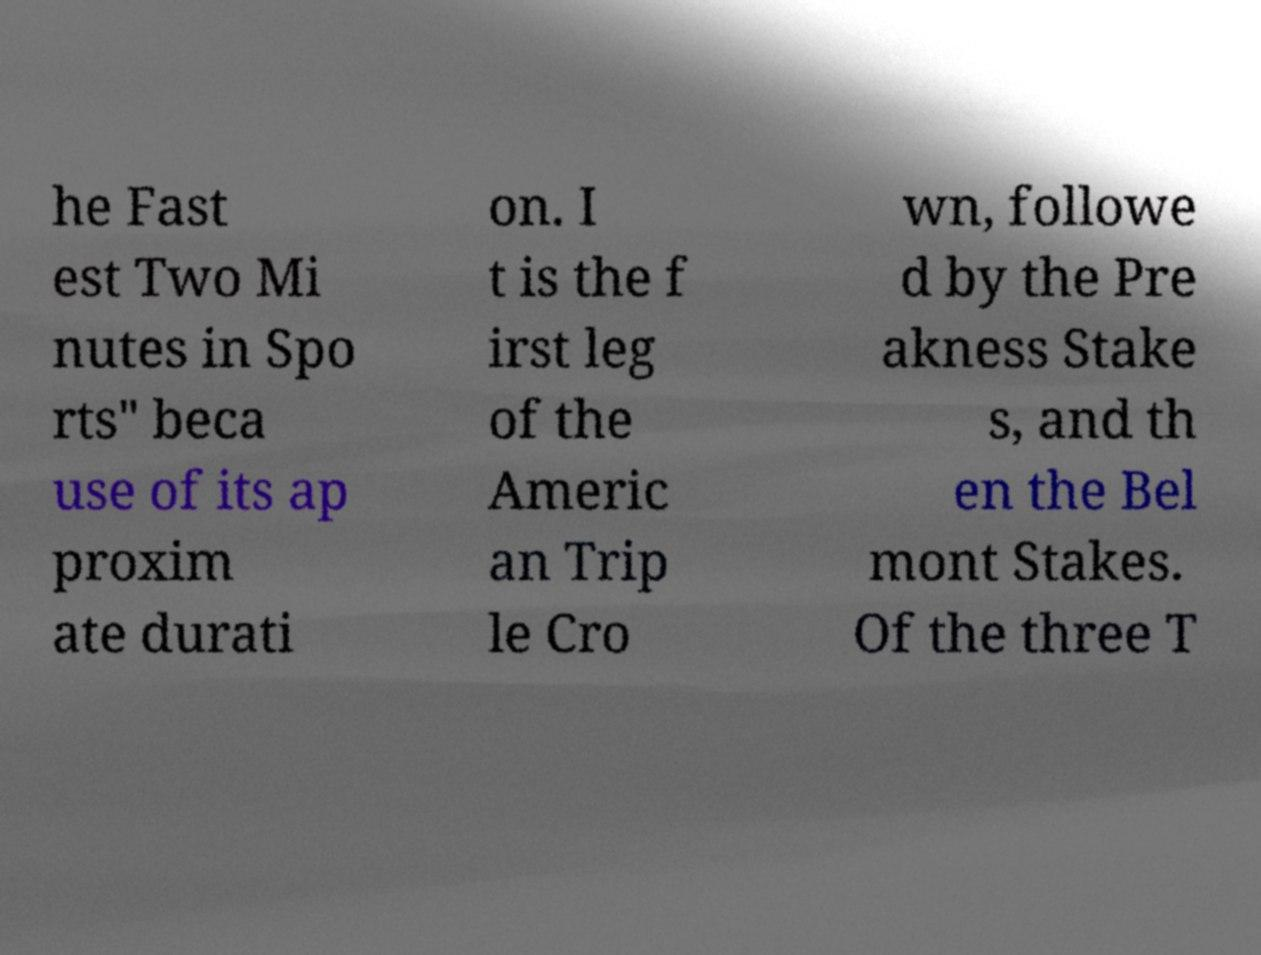I need the written content from this picture converted into text. Can you do that? he Fast est Two Mi nutes in Spo rts" beca use of its ap proxim ate durati on. I t is the f irst leg of the Americ an Trip le Cro wn, followe d by the Pre akness Stake s, and th en the Bel mont Stakes. Of the three T 